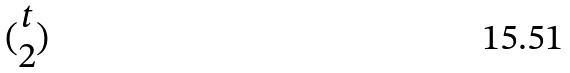<formula> <loc_0><loc_0><loc_500><loc_500>( \begin{matrix} t \\ 2 \end{matrix} )</formula> 